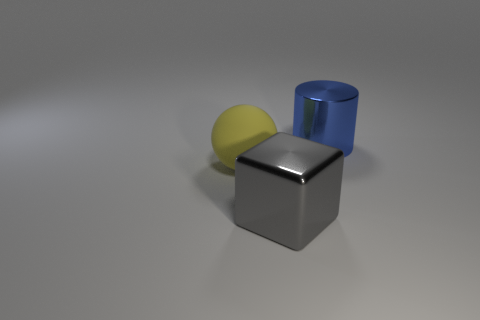Add 2 large yellow objects. How many objects exist? 5 Subtract all blocks. How many objects are left? 2 Subtract all gray rubber things. Subtract all metallic objects. How many objects are left? 1 Add 1 gray cubes. How many gray cubes are left? 2 Add 1 big yellow matte objects. How many big yellow matte objects exist? 2 Subtract 0 yellow cylinders. How many objects are left? 3 